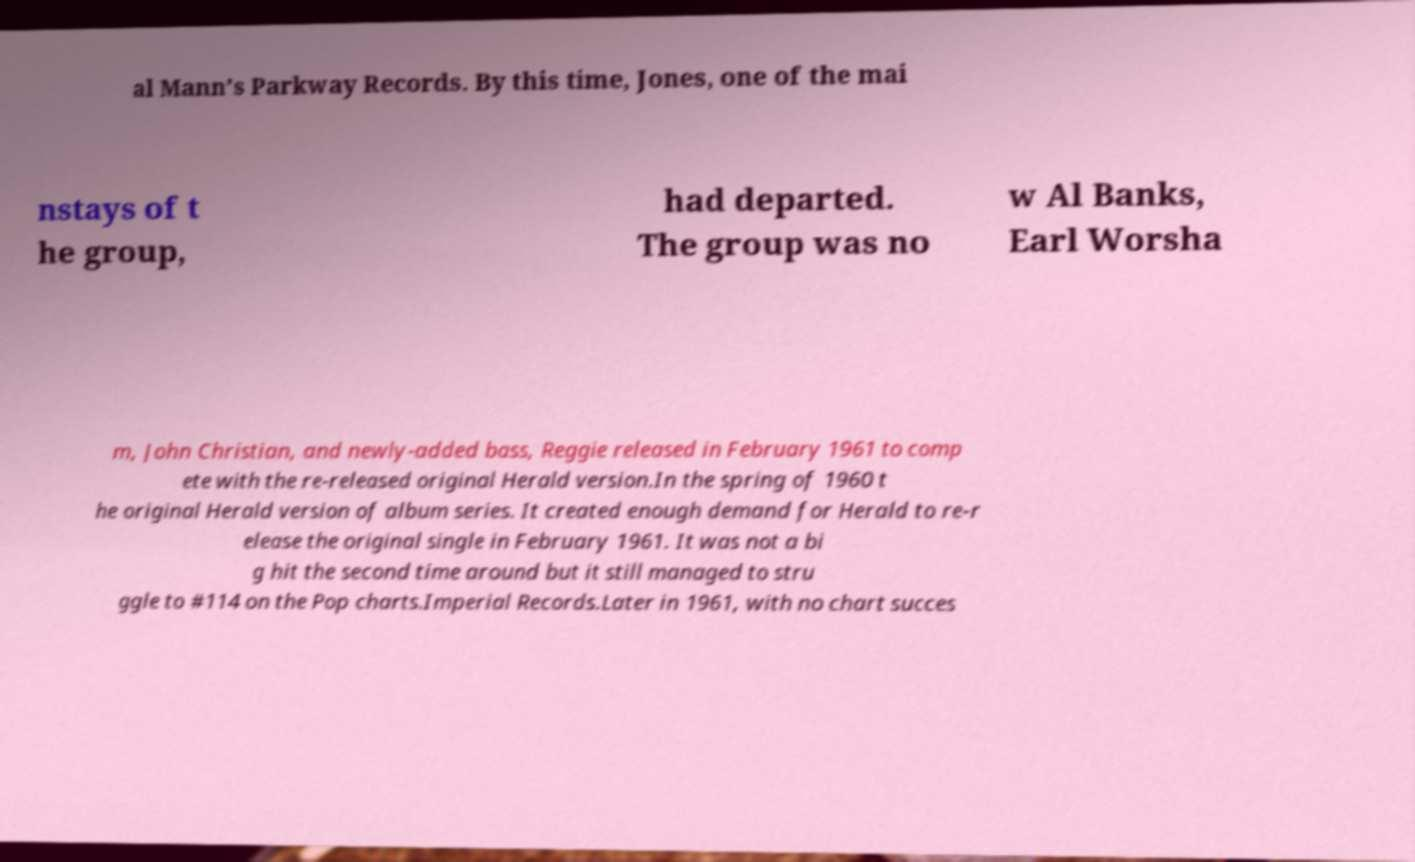Could you extract and type out the text from this image? al Mann’s Parkway Records. By this time, Jones, one of the mai nstays of t he group, had departed. The group was no w Al Banks, Earl Worsha m, John Christian, and newly-added bass, Reggie released in February 1961 to comp ete with the re-released original Herald version.In the spring of 1960 t he original Herald version of album series. It created enough demand for Herald to re-r elease the original single in February 1961. It was not a bi g hit the second time around but it still managed to stru ggle to #114 on the Pop charts.Imperial Records.Later in 1961, with no chart succes 